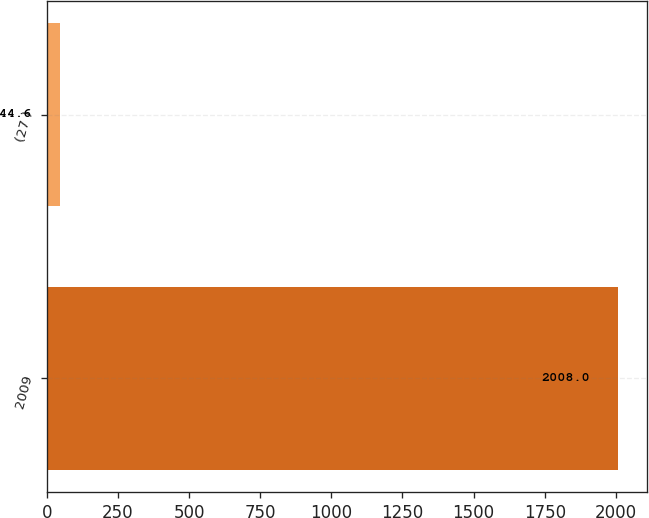Convert chart to OTSL. <chart><loc_0><loc_0><loc_500><loc_500><bar_chart><fcel>2009<fcel>(27 )<nl><fcel>2008<fcel>44.6<nl></chart> 